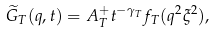<formula> <loc_0><loc_0><loc_500><loc_500>\widetilde { G } _ { T } ( q , t ) = A _ { T } ^ { + } t ^ { - \gamma _ { T } } f _ { T } ( q ^ { 2 } \xi ^ { 2 } ) ,</formula> 